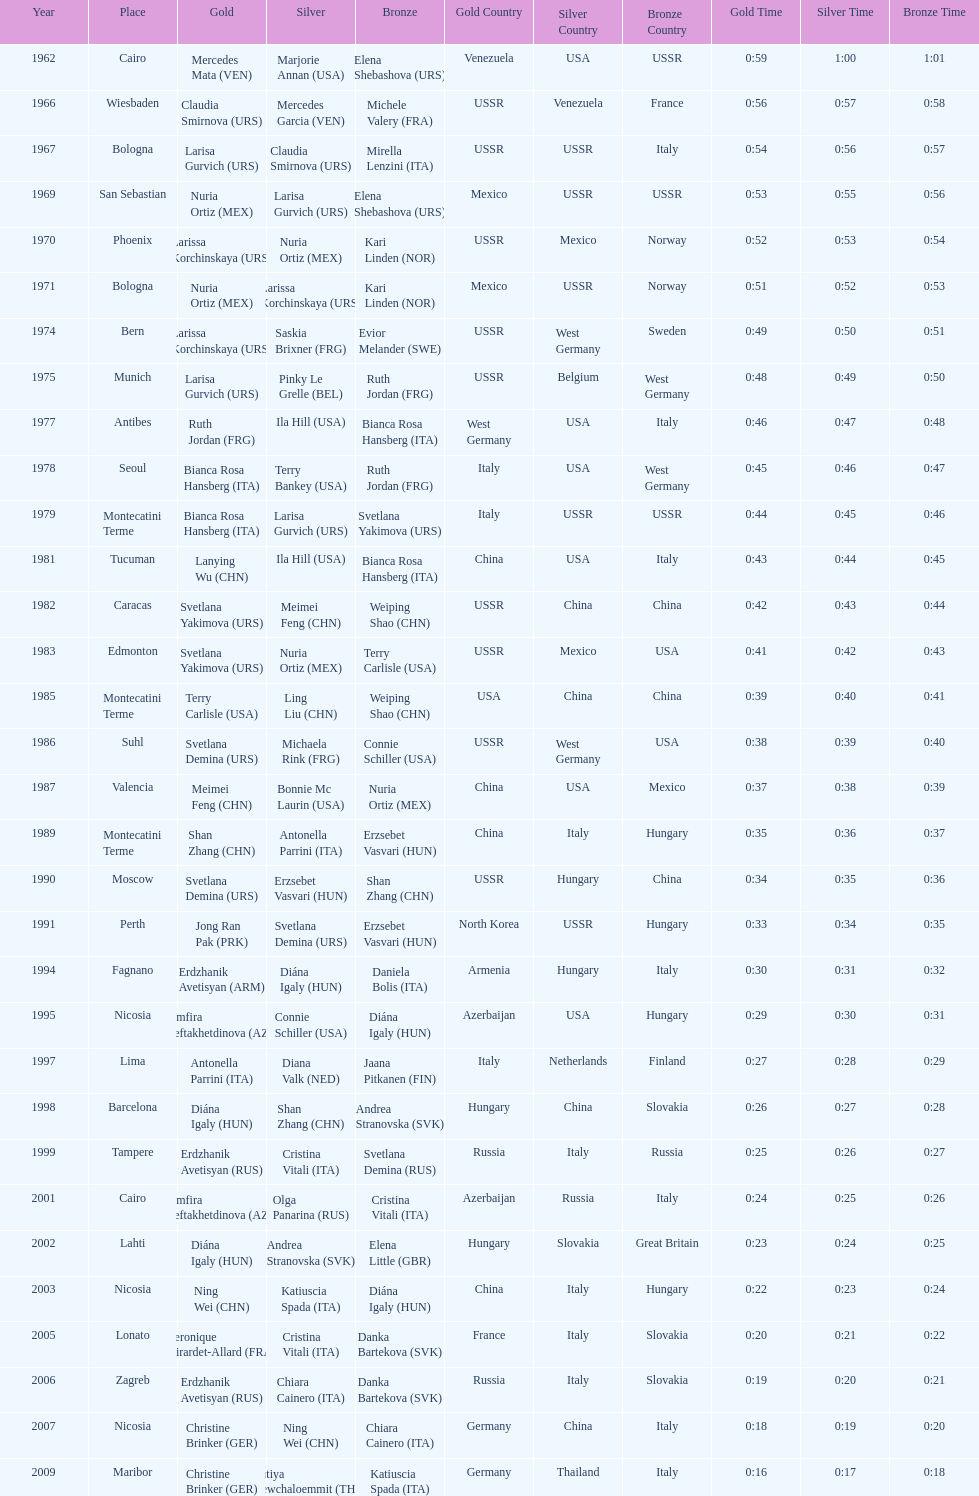Which country has won more gold medals: china or mexico? China. 